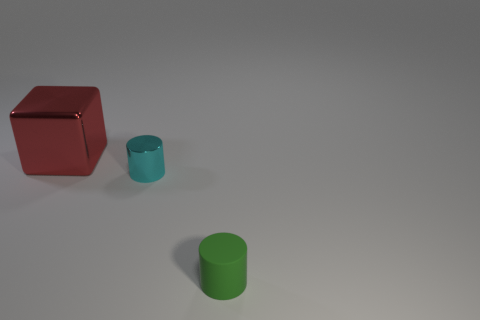Are there any other things that have the same material as the green cylinder?
Your response must be concise. No. Are there any other things that have the same shape as the small green thing?
Give a very brief answer. Yes. Are the cylinder that is right of the small cyan object and the tiny cyan object made of the same material?
Keep it short and to the point. No. There is a thing that is both in front of the block and on the left side of the small green rubber thing; what is its shape?
Keep it short and to the point. Cylinder. Is there a large shiny block that is behind the metal object to the right of the large red object?
Your response must be concise. Yes. What number of other objects are the same material as the large thing?
Offer a very short reply. 1. There is a thing in front of the cyan cylinder; is its shape the same as the shiny object behind the tiny cyan shiny cylinder?
Provide a succinct answer. No. Does the big red cube have the same material as the small green thing?
Offer a very short reply. No. There is a thing that is to the right of the cylinder that is to the left of the cylinder in front of the cyan object; what is its size?
Keep it short and to the point. Small. What is the shape of the cyan shiny object that is the same size as the green rubber thing?
Provide a succinct answer. Cylinder. 